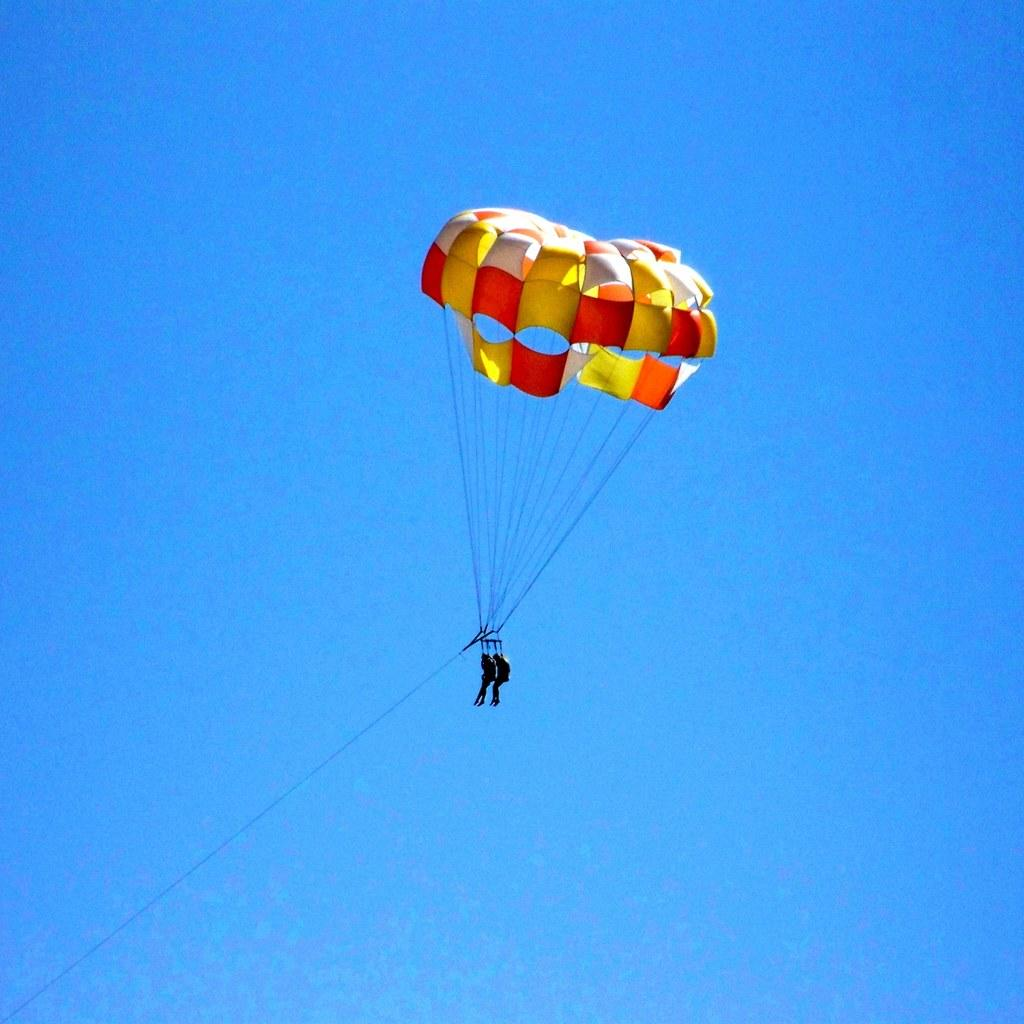What are the two persons in the image doing? The two persons in the image are paragliding. What equipment is being used for paragliding? The paragliding equipment includes a parachute. What is the condition of the sky in the image? The sky is clear in the image. What type of trousers is the monkey wearing while walking in the cemetery in the image? There is no monkey or cemetery present in the image; it features two persons paragliding with a clear sky. 